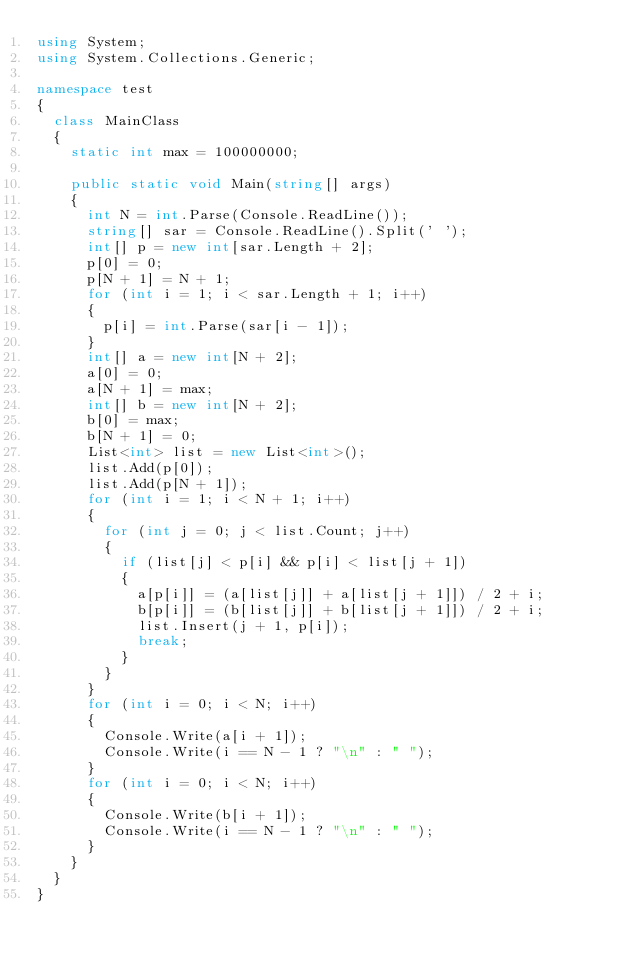<code> <loc_0><loc_0><loc_500><loc_500><_C#_>using System;
using System.Collections.Generic;

namespace test
{
	class MainClass
	{
		static int max = 100000000;

		public static void Main(string[] args)
		{
			int N = int.Parse(Console.ReadLine());
			string[] sar = Console.ReadLine().Split(' ');
			int[] p = new int[sar.Length + 2];
			p[0] = 0;
			p[N + 1] = N + 1;
			for (int i = 1; i < sar.Length + 1; i++)
			{
				p[i] = int.Parse(sar[i - 1]);
			}
			int[] a = new int[N + 2];
			a[0] = 0;
			a[N + 1] = max;
			int[] b = new int[N + 2];
			b[0] = max;
			b[N + 1] = 0;
			List<int> list = new List<int>();
			list.Add(p[0]);
			list.Add(p[N + 1]);
			for (int i = 1; i < N + 1; i++)
			{
				for (int j = 0; j < list.Count; j++)
				{
					if (list[j] < p[i] && p[i] < list[j + 1])
					{
						a[p[i]] = (a[list[j]] + a[list[j + 1]]) / 2 + i;
						b[p[i]] = (b[list[j]] + b[list[j + 1]]) / 2 + i;
						list.Insert(j + 1, p[i]);
						break;
					}						
				}
			}
			for (int i = 0; i < N; i++)
			{
				Console.Write(a[i + 1]);
				Console.Write(i == N - 1 ? "\n" : " ");
			}
			for (int i = 0; i < N; i++)
			{
				Console.Write(b[i + 1]);
				Console.Write(i == N - 1 ? "\n" : " ");
			}
		}
	}
}
</code> 